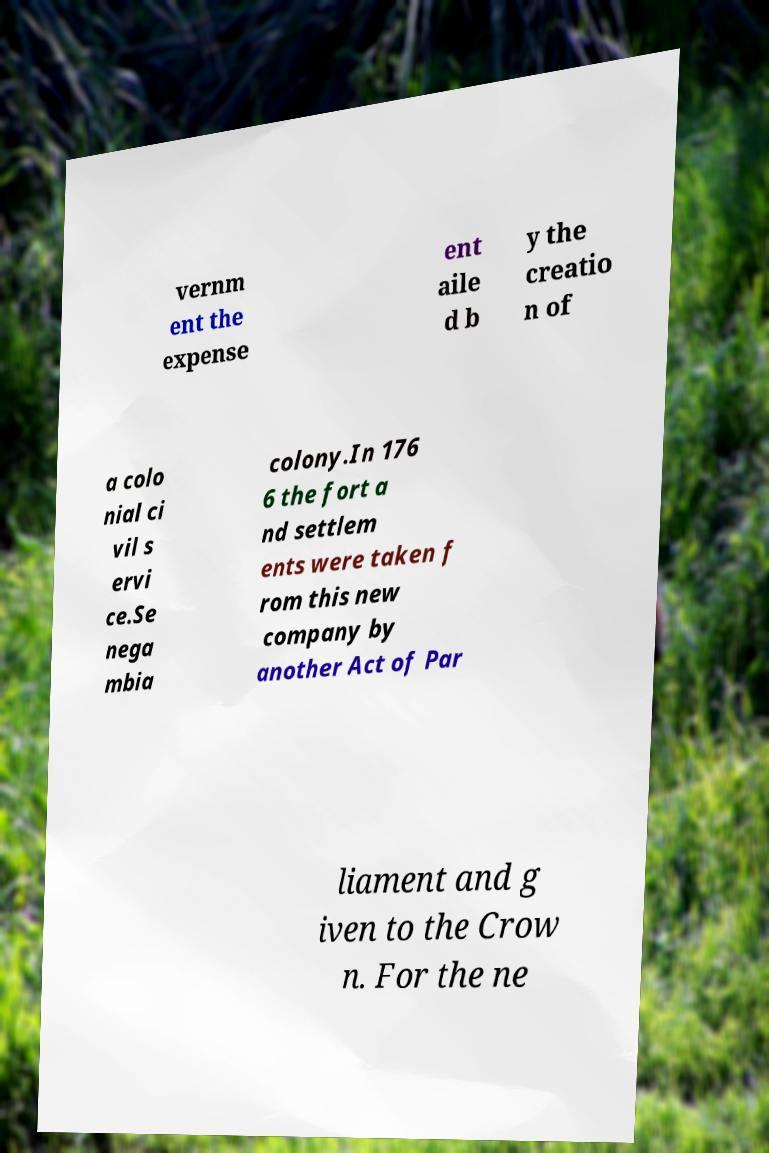Please identify and transcribe the text found in this image. vernm ent the expense ent aile d b y the creatio n of a colo nial ci vil s ervi ce.Se nega mbia colony.In 176 6 the fort a nd settlem ents were taken f rom this new company by another Act of Par liament and g iven to the Crow n. For the ne 